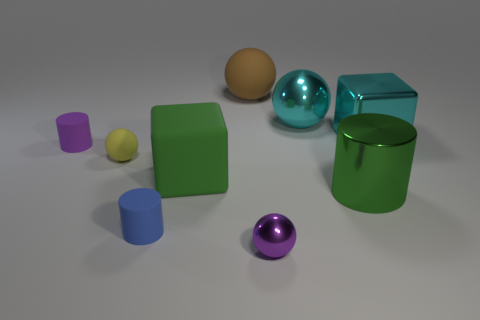What number of big cyan things are both right of the green cylinder and on the left side of the green cylinder?
Give a very brief answer. 0. There is a yellow matte object behind the big green thing that is left of the metal sphere that is in front of the yellow matte thing; what shape is it?
Provide a succinct answer. Sphere. Is there anything else that has the same shape as the yellow object?
Provide a short and direct response. Yes. How many cylinders are tiny yellow objects or brown matte things?
Provide a succinct answer. 0. Is the color of the rubber ball behind the big metallic sphere the same as the small metallic object?
Your answer should be very brief. No. There is a object that is behind the cyan metallic object that is behind the cube that is on the right side of the cyan sphere; what is its material?
Ensure brevity in your answer.  Rubber. Do the brown matte object and the cyan sphere have the same size?
Your response must be concise. Yes. There is a metal block; is it the same color as the shiny sphere behind the matte block?
Provide a succinct answer. Yes. What shape is the small purple object that is the same material as the small blue cylinder?
Offer a terse response. Cylinder. Does the green object right of the tiny purple metal sphere have the same shape as the blue matte thing?
Keep it short and to the point. Yes. 